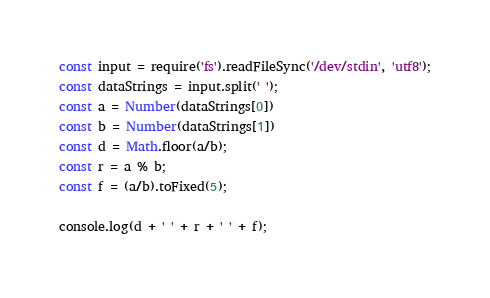Convert code to text. <code><loc_0><loc_0><loc_500><loc_500><_JavaScript_>const input = require('fs').readFileSync('/dev/stdin', 'utf8');
const dataStrings = input.split(' ');
const a = Number(dataStrings[0])
const b = Number(dataStrings[1])
const d = Math.floor(a/b);
const r = a % b;
const f = (a/b).toFixed(5);

console.log(d + ' ' + r + ' ' + f);
</code> 